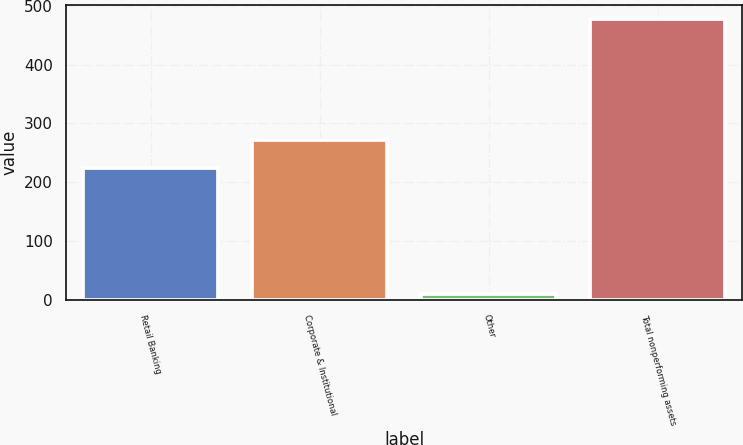Convert chart. <chart><loc_0><loc_0><loc_500><loc_500><bar_chart><fcel>Retail Banking<fcel>Corporate & Institutional<fcel>Other<fcel>Total nonperforming assets<nl><fcel>225<fcel>271.8<fcel>10<fcel>478<nl></chart> 